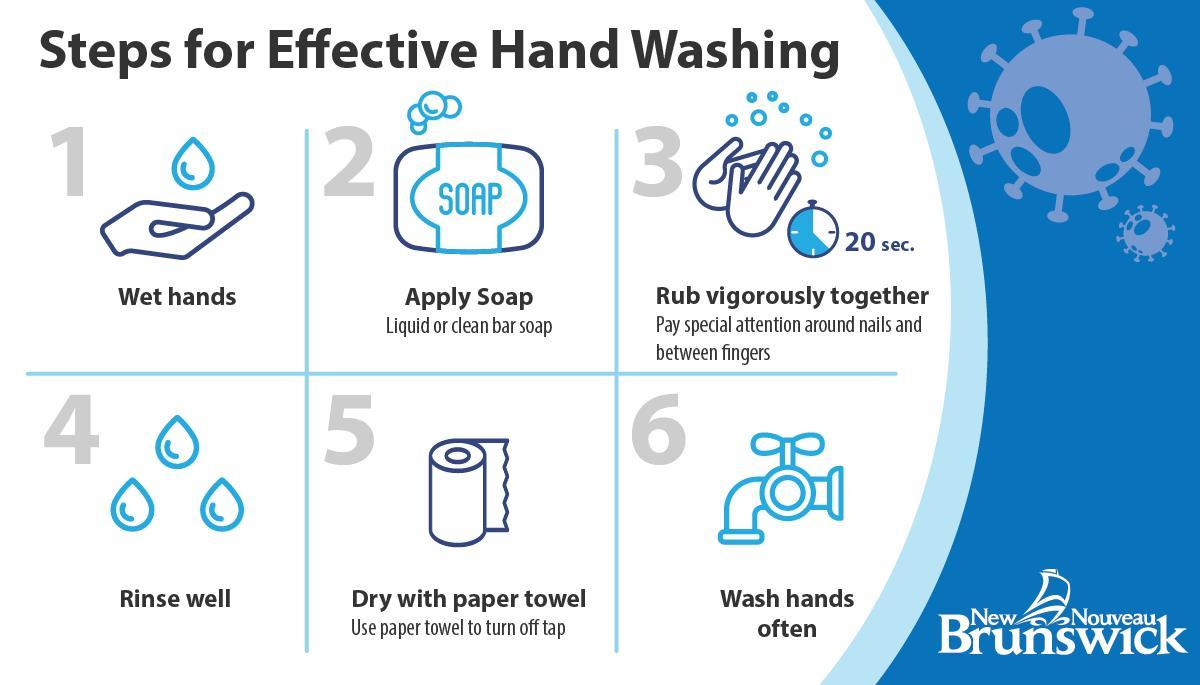What should you do after rinsing your hands?
Answer the question with a short phrase. Dry with paper towel What is the fourth step for effective hand washing? Rinse well What are are the first two steps effects of handwashing? Wet hands, apply soap How many times does the image of a tap appear? 1 For how long are you expected to rub your hands with soap? 20 sec. What is the instruction given regarding closing the tap? Use paper towel to turn off tap What should you do after applying soap? Rub vigorously together 